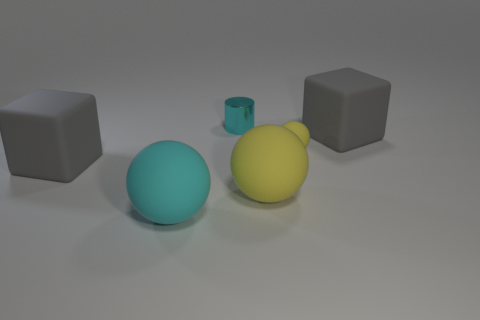Add 1 yellow metal things. How many objects exist? 7 Subtract all cylinders. How many objects are left? 5 Add 4 rubber things. How many rubber things are left? 9 Add 6 small cyan metal cylinders. How many small cyan metal cylinders exist? 7 Subtract 2 yellow balls. How many objects are left? 4 Subtract all large gray rubber objects. Subtract all rubber blocks. How many objects are left? 2 